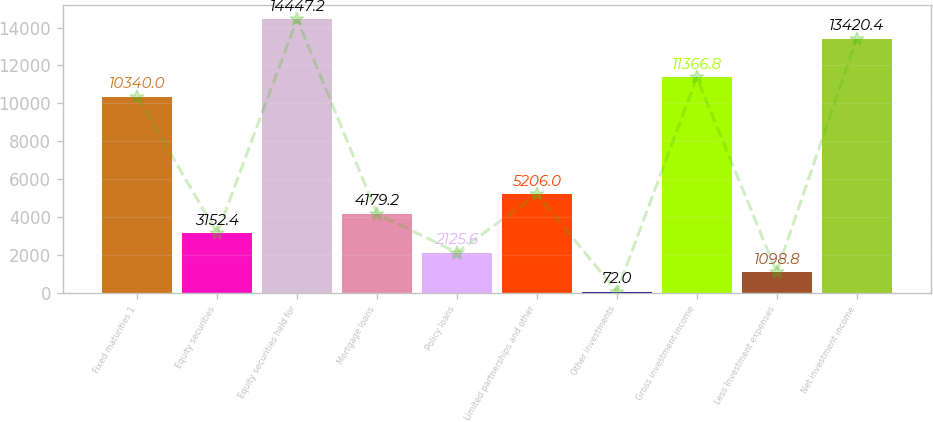Convert chart. <chart><loc_0><loc_0><loc_500><loc_500><bar_chart><fcel>Fixed maturities 1<fcel>Equity securities<fcel>Equity securities held for<fcel>Mortgage loans<fcel>Policy loans<fcel>Limited partnerships and other<fcel>Other investments<fcel>Gross investment income<fcel>Less Investment expenses<fcel>Net investment income<nl><fcel>10340<fcel>3152.4<fcel>14447.2<fcel>4179.2<fcel>2125.6<fcel>5206<fcel>72<fcel>11366.8<fcel>1098.8<fcel>13420.4<nl></chart> 